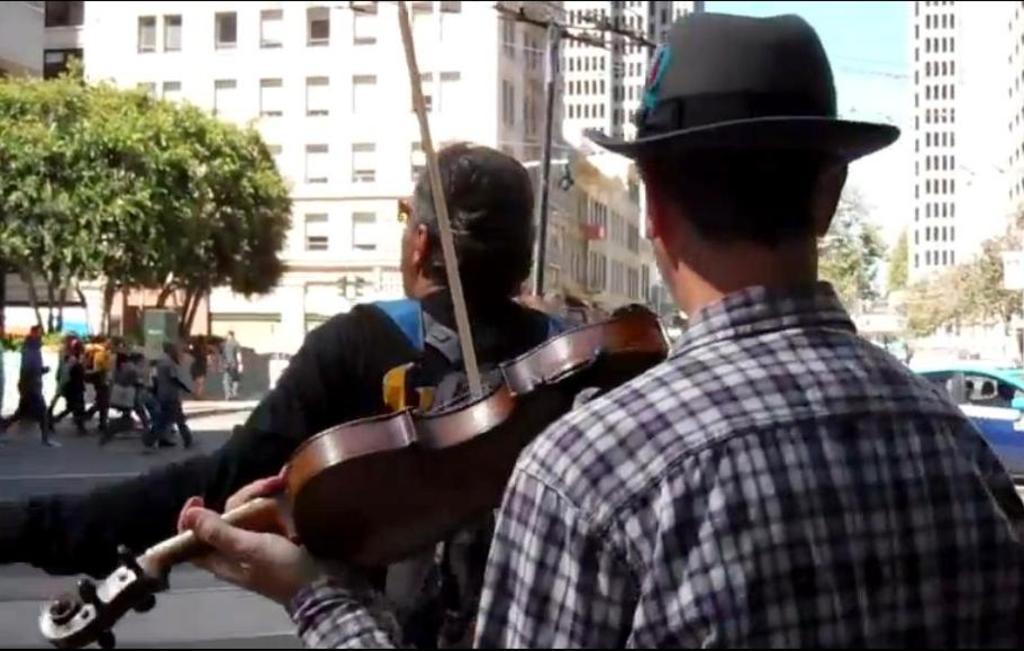Can you describe this image briefly? In this image, There is a person standing and playing a violin. There is a person standing who is standing behind this person and wearing bag. There are some persons walking on the road. There is a building and tree in front of this person. There is a sky and car in front of this person. This person is wearing hat on his head. There is pole in front of this person. 